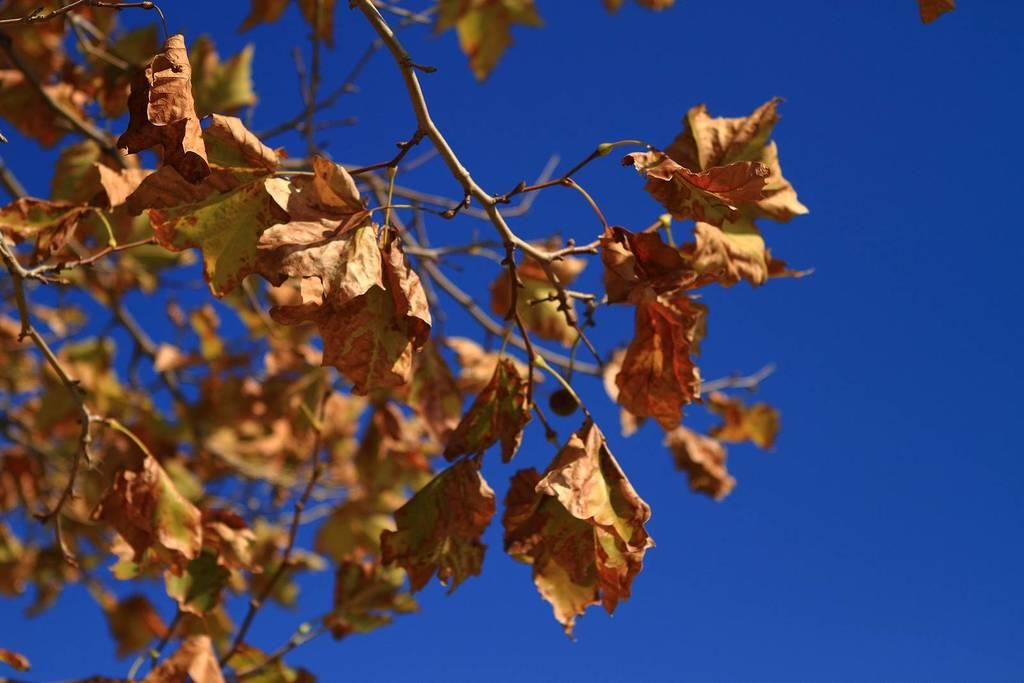What type of natural elements are present in the image? The image contains leaves and branches. What is the color of the background in the image? The background of the image is blue in color. Can you see a bird playing a drum on the branches in the image? There is no bird or drum present in the image; it only contains leaves and branches against a blue background. 